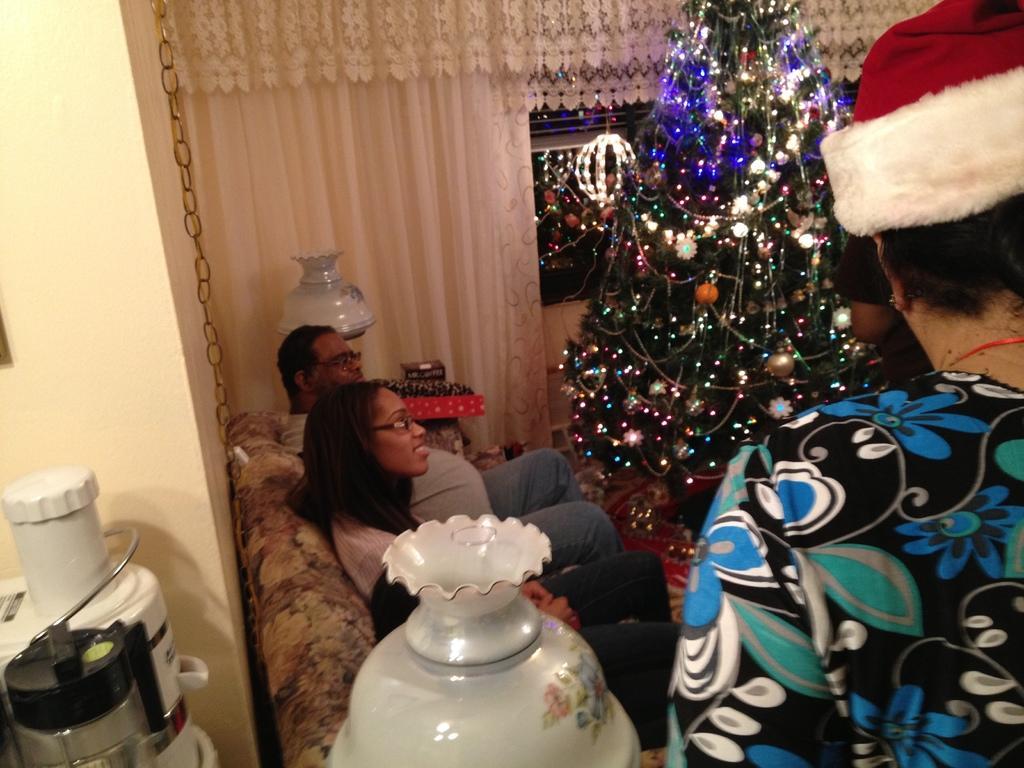Describe this image in one or two sentences. In this image we can see persons sitting on the sofa and a woman standing. In the background we can see christmas tree, curtain, food processors and vases. 